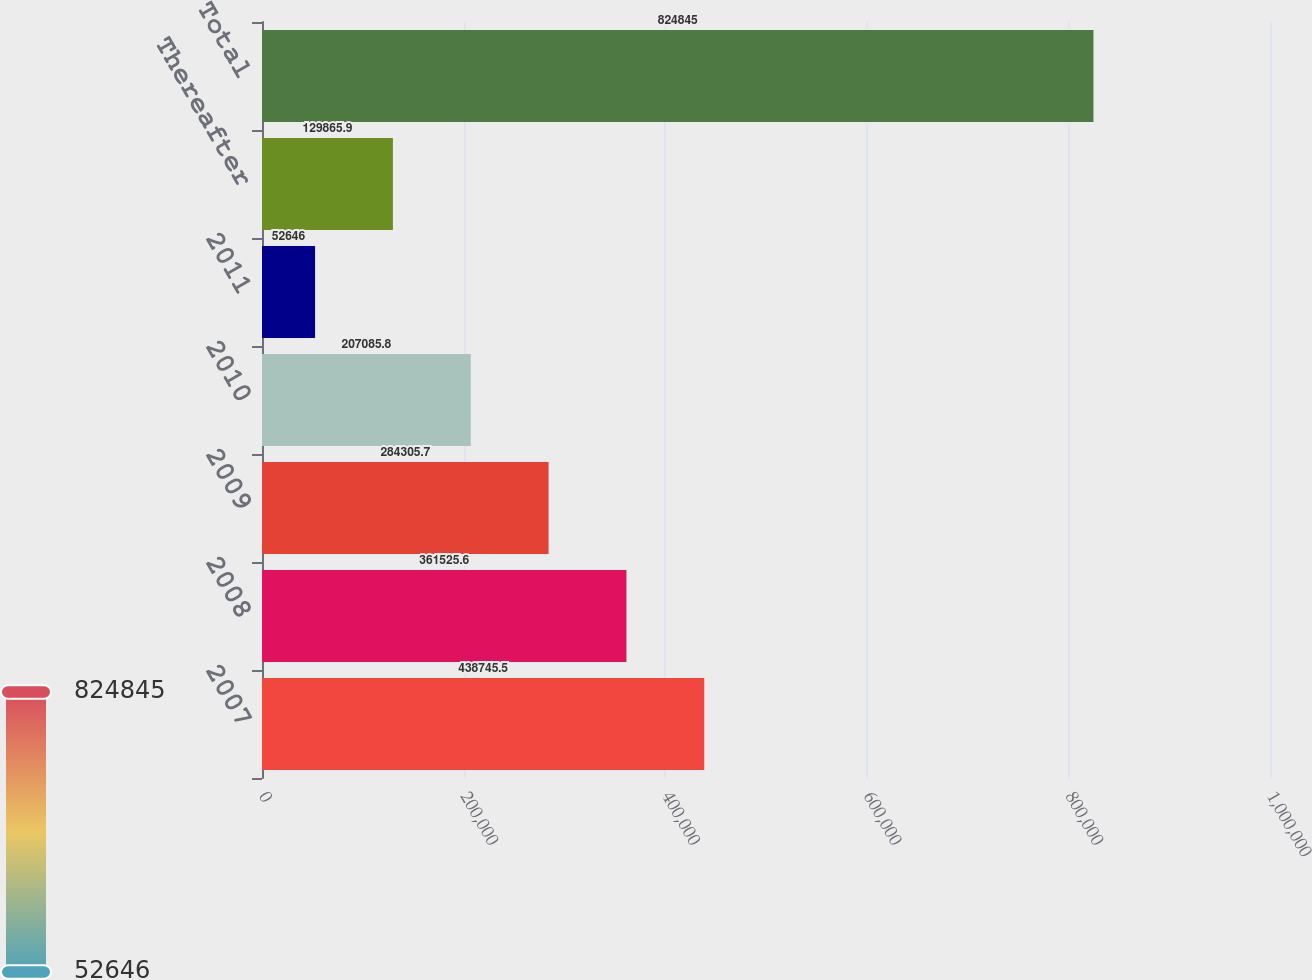Convert chart. <chart><loc_0><loc_0><loc_500><loc_500><bar_chart><fcel>2007<fcel>2008<fcel>2009<fcel>2010<fcel>2011<fcel>Thereafter<fcel>Total<nl><fcel>438746<fcel>361526<fcel>284306<fcel>207086<fcel>52646<fcel>129866<fcel>824845<nl></chart> 